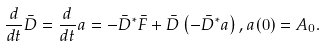Convert formula to latex. <formula><loc_0><loc_0><loc_500><loc_500>\frac { d } { d t } \bar { D } = \frac { d } { d t } a = - \bar { D } ^ { * } \bar { F } + \bar { D } \left ( - \bar { D } ^ { * } a \right ) , a ( 0 ) = A _ { 0 } .</formula> 